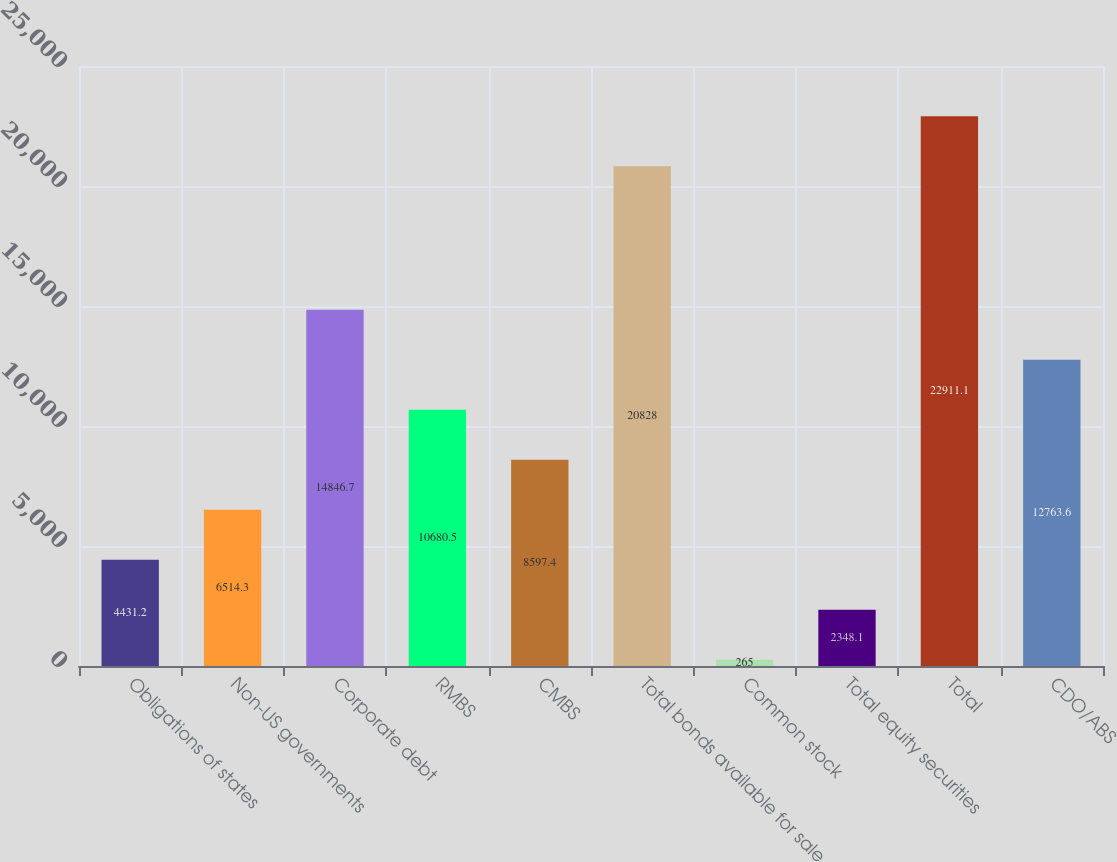<chart> <loc_0><loc_0><loc_500><loc_500><bar_chart><fcel>Obligations of states<fcel>Non-US governments<fcel>Corporate debt<fcel>RMBS<fcel>CMBS<fcel>Total bonds available for sale<fcel>Common stock<fcel>Total equity securities<fcel>Total<fcel>CDO/ABS<nl><fcel>4431.2<fcel>6514.3<fcel>14846.7<fcel>10680.5<fcel>8597.4<fcel>20828<fcel>265<fcel>2348.1<fcel>22911.1<fcel>12763.6<nl></chart> 